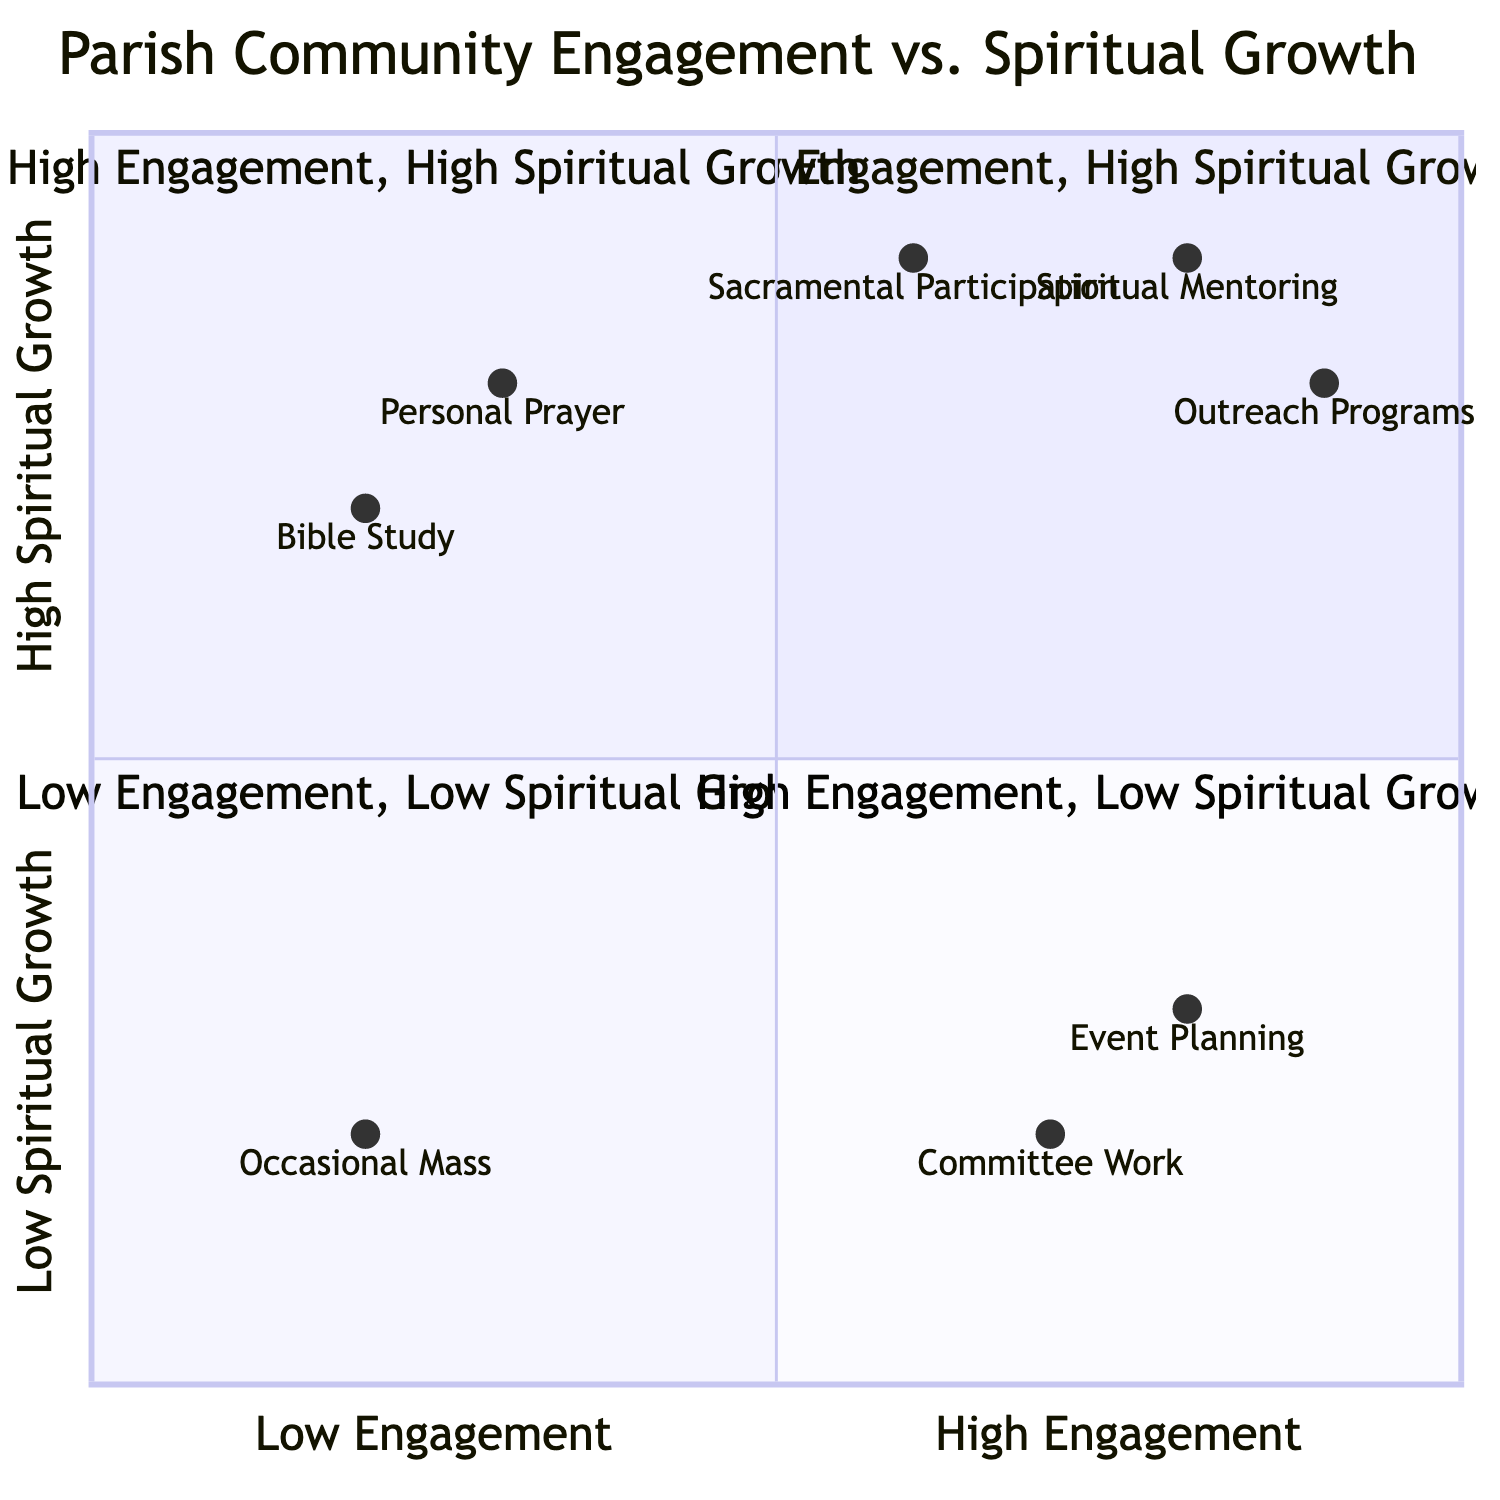What is the color representing Low Engagement, Low Spiritual Growth? According to the diagram, the section for Low Engagement and Low Spiritual Growth is color-coded light grey.
Answer: light grey How many activities are listed for High Engagement, High Spiritual Growth? The High Engagement, High Spiritual Growth quadrant includes four activities: Leading Bible study groups, Volunteering in church outreach programs. Therefore, the total count is two activities.
Answer: 2 Which quadrant represents individuals who are not very involved in the community but focus on spiritual practices? The quadrant describing individuals who focus on spiritual practices with low community involvement is labeled Low Engagement, High Spiritual Growth.
Answer: Low Engagement, High Spiritual Growth What is an activity listed for High Engagement, Low Spiritual Growth? One of the activities listed for the High Engagement, Low Spiritual Growth quadrant is organizing events. This indicates that individuals in this group are active in community events but may not deepen their spiritual journey.
Answer: organizing events Which spiritual practice is common in the High Engagement, High Spiritual Growth quadrant? The High Engagement, High Spiritual Growth quadrant includes several spiritual practices, one of which is regular participation in the sacraments, indicating a commitment to spiritual growth alongside community involvement.
Answer: regular participation in the sacraments How does the Low Engagement, Low Spiritual Growth quadrant describe individuals? This quadrant describes individuals as being either new to the parish or disconnected from both the community and the spiritual activities offered.
Answer: new to the parish or disconnected Which icon represents the High Engagement, High Spiritual Growth quadrant? The High Engagement, High Spiritual Growth quadrant is represented by the unity icon, symbolizing the integration of community involvement and personal spiritual journey.
Answer: unity What is the main challenge for individuals in the High Engagement, Low Spiritual Growth quadrant? Individuals in the High Engagement, Low Spiritual Growth quadrant face the challenge of struggling to deepen their spiritual journey despite being active in community events.
Answer: deepening their spiritual journey What activity do Low Engagement, High Spiritual Growth individuals have in common with their spiritual practices? Individuals in the Low Engagement, High Spiritual Growth quadrant share the activity of occasional attendance at Mass, indicating reluctance to engage more deeply with the community despite strong spiritual practices.
Answer: occasional attendance at Mass 